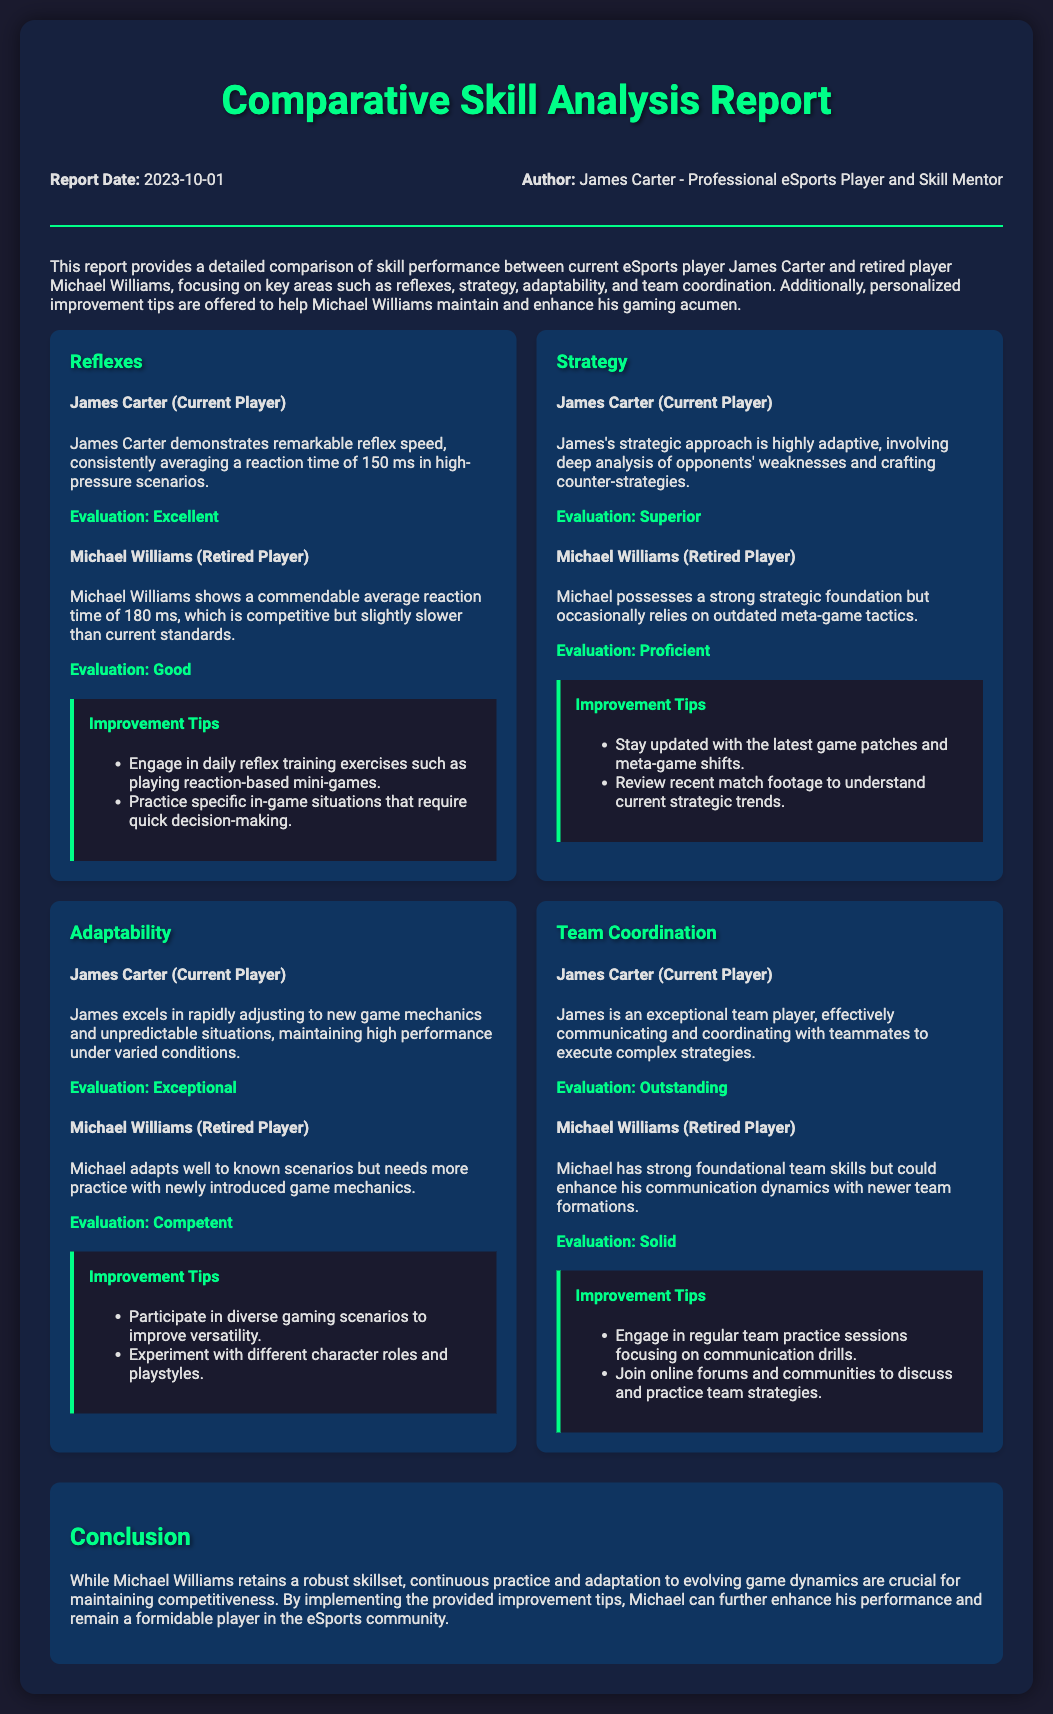what is the report date? The report date is mentioned in the header section of the document.
Answer: 2023-10-01 who authored the report? The author of the report is listed in the header section.
Answer: James Carter - Professional eSports Player and Skill Mentor how fast is James Carter's average reaction time? The average reaction time for James Carter is provided under the reflexes section.
Answer: 150 ms what is Michael Williams' evaluation for team coordination? The evaluation for Michael Williams regarding team coordination is found in the relevant skill card.
Answer: Solid what key area does the report focus on? The report focuses on key areas such as reflexes, strategy, adaptability, and team coordination, which are explicitly stated in the introduction.
Answer: Reflexes, strategy, adaptability, team coordination how does James Carter's strategic evaluation compare to Michael Williams'? This requires comparing the evaluations for both players in the strategy section.
Answer: Superior vs Proficient what type of tips are provided for improvement? Improvement tips are provided for each skill area as listed in the improvement tips section.
Answer: Personalized improvement tips what is the evaluation for Michael Williams' adaptability? The evaluation for Michael Williams regarding adaptability is revealed in the adaptability skill card.
Answer: Competent 